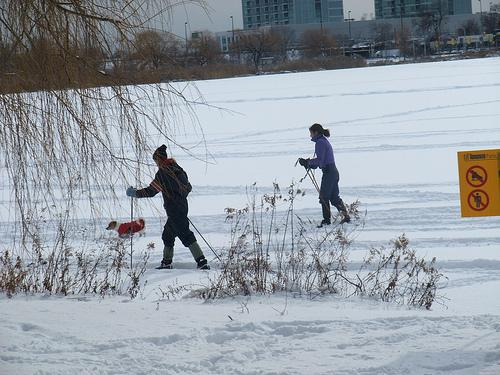Question: what color is the tree?
Choices:
A. Black.
B. Brown.
C. Green.
D. Red.
Answer with the letter. Answer: B Question: what are the people doing?
Choices:
A. Playing in the pool.
B. Eating dinner.
C. Playing in the snow.
D. Playing games.
Answer with the letter. Answer: C 